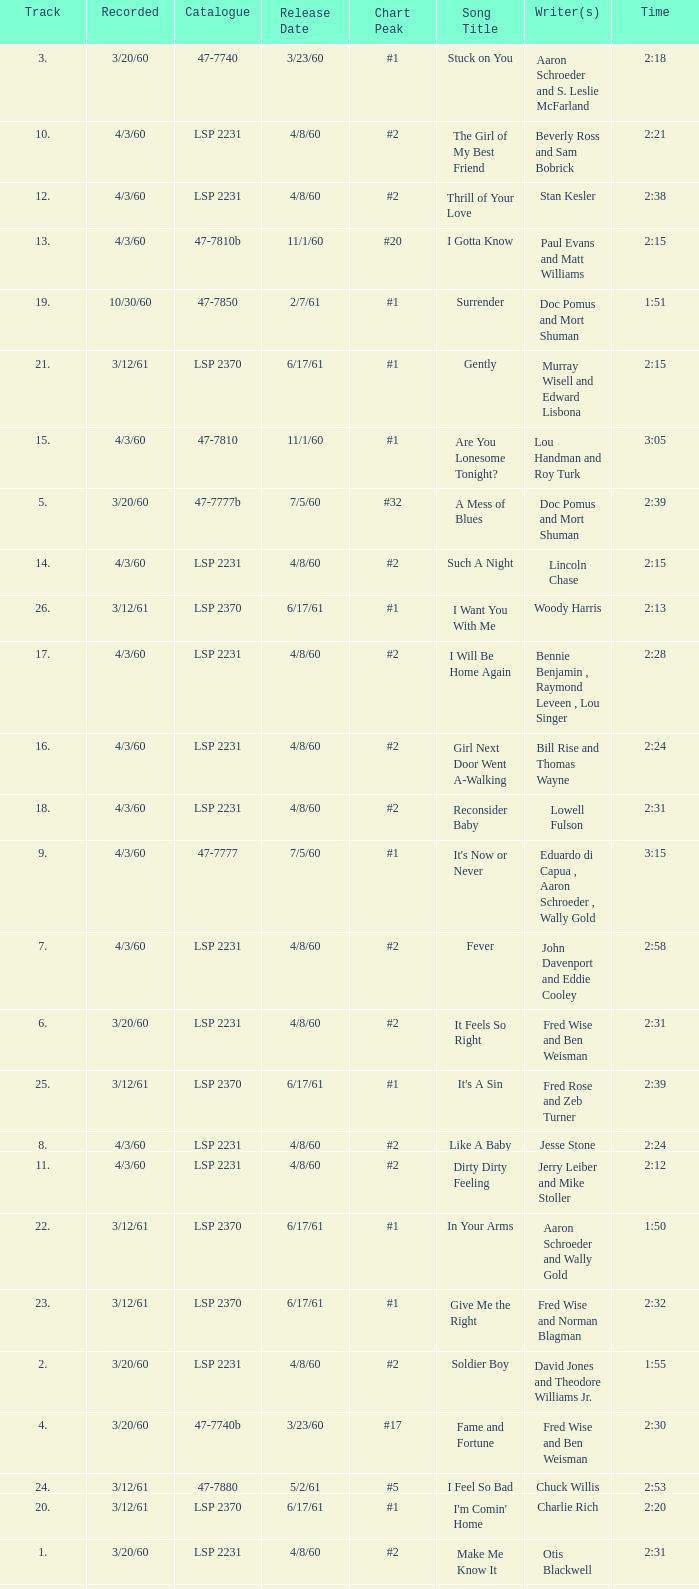On songs with track numbers smaller than number 17 and catalogues of LSP 2231, who are the writer(s)? Otis Blackwell, David Jones and Theodore Williams Jr., Fred Wise and Ben Weisman, John Davenport and Eddie Cooley, Jesse Stone, Beverly Ross and Sam Bobrick, Jerry Leiber and Mike Stoller, Stan Kesler, Lincoln Chase, Bill Rise and Thomas Wayne. 